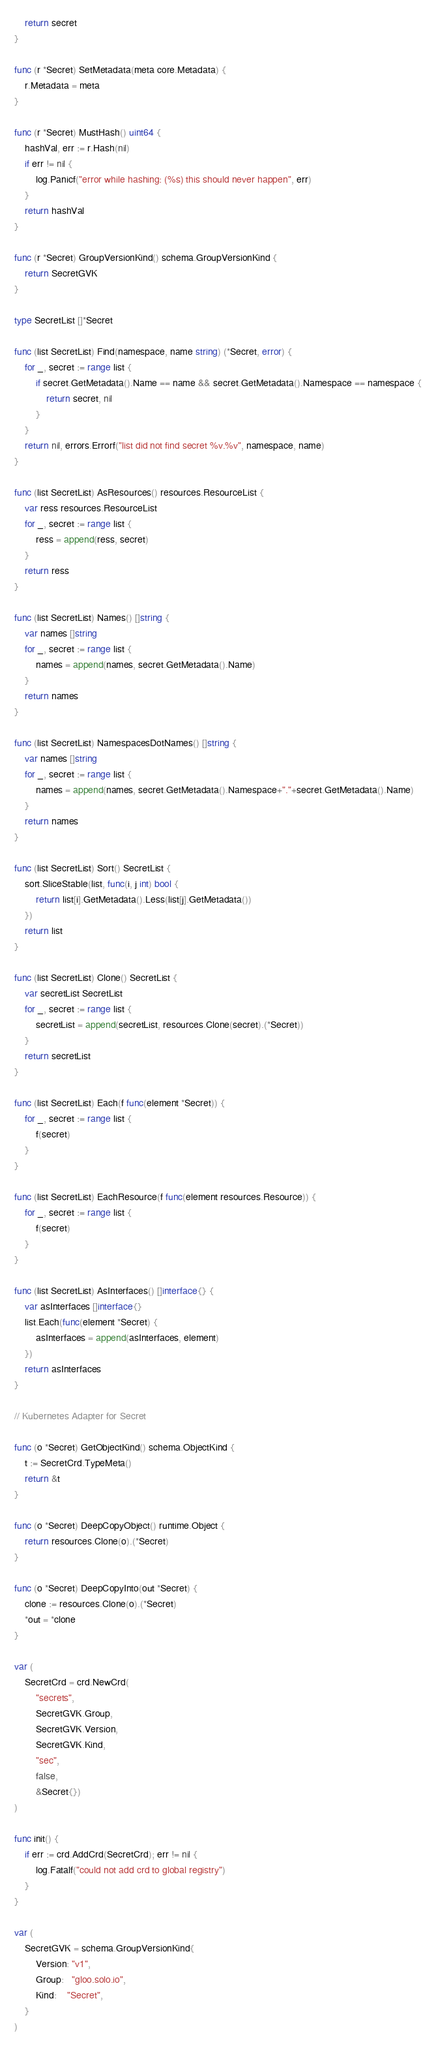Convert code to text. <code><loc_0><loc_0><loc_500><loc_500><_Go_>	return secret
}

func (r *Secret) SetMetadata(meta core.Metadata) {
	r.Metadata = meta
}

func (r *Secret) MustHash() uint64 {
	hashVal, err := r.Hash(nil)
	if err != nil {
		log.Panicf("error while hashing: (%s) this should never happen", err)
	}
	return hashVal
}

func (r *Secret) GroupVersionKind() schema.GroupVersionKind {
	return SecretGVK
}

type SecretList []*Secret

func (list SecretList) Find(namespace, name string) (*Secret, error) {
	for _, secret := range list {
		if secret.GetMetadata().Name == name && secret.GetMetadata().Namespace == namespace {
			return secret, nil
		}
	}
	return nil, errors.Errorf("list did not find secret %v.%v", namespace, name)
}

func (list SecretList) AsResources() resources.ResourceList {
	var ress resources.ResourceList
	for _, secret := range list {
		ress = append(ress, secret)
	}
	return ress
}

func (list SecretList) Names() []string {
	var names []string
	for _, secret := range list {
		names = append(names, secret.GetMetadata().Name)
	}
	return names
}

func (list SecretList) NamespacesDotNames() []string {
	var names []string
	for _, secret := range list {
		names = append(names, secret.GetMetadata().Namespace+"."+secret.GetMetadata().Name)
	}
	return names
}

func (list SecretList) Sort() SecretList {
	sort.SliceStable(list, func(i, j int) bool {
		return list[i].GetMetadata().Less(list[j].GetMetadata())
	})
	return list
}

func (list SecretList) Clone() SecretList {
	var secretList SecretList
	for _, secret := range list {
		secretList = append(secretList, resources.Clone(secret).(*Secret))
	}
	return secretList
}

func (list SecretList) Each(f func(element *Secret)) {
	for _, secret := range list {
		f(secret)
	}
}

func (list SecretList) EachResource(f func(element resources.Resource)) {
	for _, secret := range list {
		f(secret)
	}
}

func (list SecretList) AsInterfaces() []interface{} {
	var asInterfaces []interface{}
	list.Each(func(element *Secret) {
		asInterfaces = append(asInterfaces, element)
	})
	return asInterfaces
}

// Kubernetes Adapter for Secret

func (o *Secret) GetObjectKind() schema.ObjectKind {
	t := SecretCrd.TypeMeta()
	return &t
}

func (o *Secret) DeepCopyObject() runtime.Object {
	return resources.Clone(o).(*Secret)
}

func (o *Secret) DeepCopyInto(out *Secret) {
	clone := resources.Clone(o).(*Secret)
	*out = *clone
}

var (
	SecretCrd = crd.NewCrd(
		"secrets",
		SecretGVK.Group,
		SecretGVK.Version,
		SecretGVK.Kind,
		"sec",
		false,
		&Secret{})
)

func init() {
	if err := crd.AddCrd(SecretCrd); err != nil {
		log.Fatalf("could not add crd to global registry")
	}
}

var (
	SecretGVK = schema.GroupVersionKind{
		Version: "v1",
		Group:   "gloo.solo.io",
		Kind:    "Secret",
	}
)
</code> 